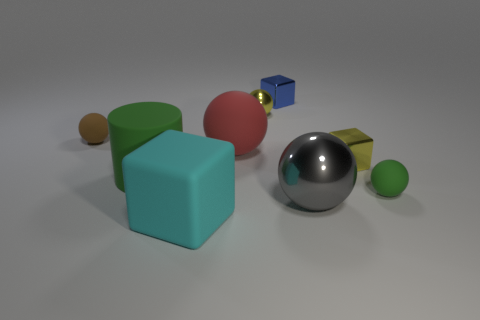How many things are either big gray spheres that are in front of the big red ball or objects that are in front of the yellow ball?
Give a very brief answer. 7. There is a tiny yellow object behind the yellow object that is on the right side of the blue shiny thing; how many blue cubes are in front of it?
Your answer should be compact. 0. There is a rubber sphere in front of the large green rubber object; how big is it?
Your response must be concise. Small. How many shiny spheres are the same size as the cyan rubber object?
Your response must be concise. 1. There is a brown matte object; is its size the same as the green object on the left side of the large red rubber thing?
Provide a short and direct response. No. How many things are purple balls or green rubber balls?
Offer a very short reply. 1. What number of rubber objects have the same color as the large matte cube?
Your answer should be compact. 0. What shape is the red thing that is the same size as the cylinder?
Provide a short and direct response. Sphere. Are there any red rubber objects that have the same shape as the big cyan object?
Offer a terse response. No. How many small cubes are made of the same material as the gray thing?
Provide a succinct answer. 2. 